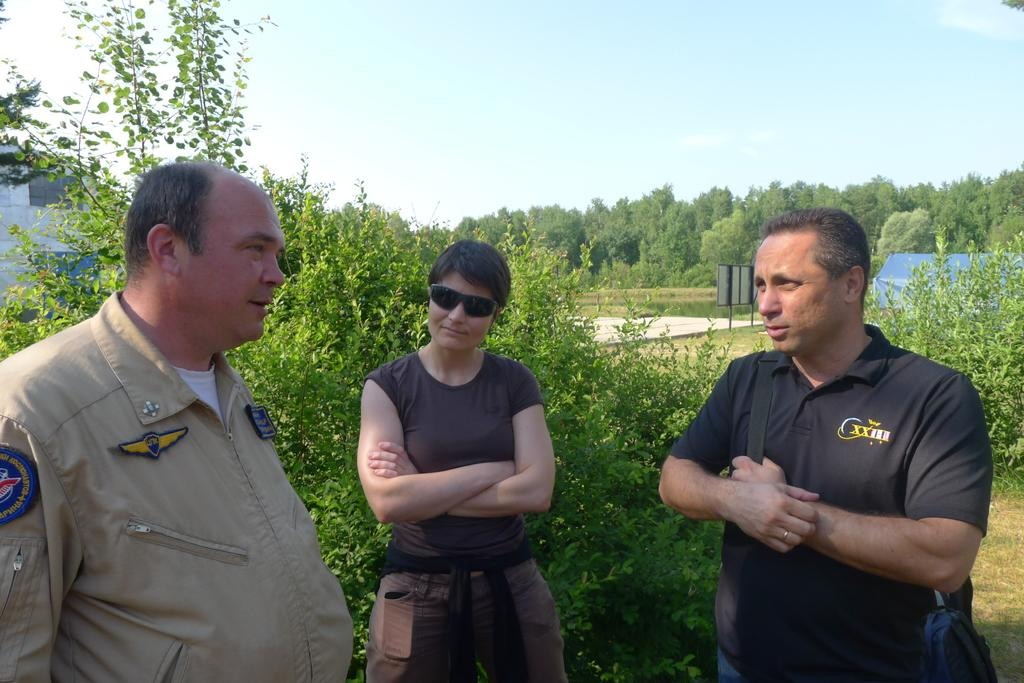How many people are standing in the image? There are three persons standing on the ground in the image. What can be seen in the background of the image? In the background, there are trees, a blue-colored tent, a board, a building, and the sky. What is the color of the trees in the background? The trees in the background are green in color. What structure is visible in the background? There is a building in the background. How does the lead affect the end of the breath in the image? There is no lead or breath present in the image; it features three persons standing on the ground with a background containing trees, a tent, a board, a building, and the sky. 